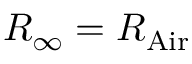<formula> <loc_0><loc_0><loc_500><loc_500>R _ { \infty } = R _ { A i r }</formula> 